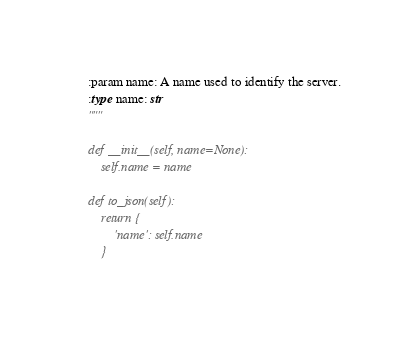<code> <loc_0><loc_0><loc_500><loc_500><_Python_>
    :param name: A name used to identify the server.
    :type name: str
    """

    def __init__(self, name=None):
        self.name = name

    def to_json(self):
        return {
            'name': self.name
        }
</code> 